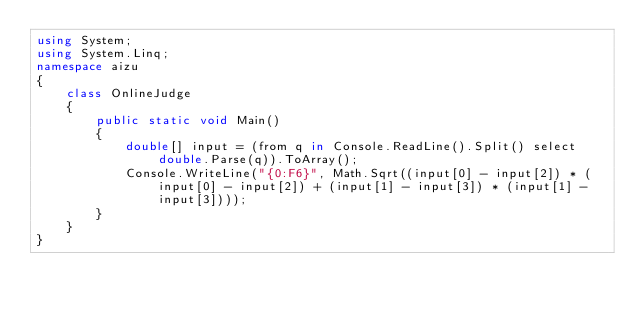Convert code to text. <code><loc_0><loc_0><loc_500><loc_500><_C#_>using System;
using System.Linq;
namespace aizu
{
    class OnlineJudge
    {
        public static void Main()
        {
            double[] input = (from q in Console.ReadLine().Split() select double.Parse(q)).ToArray();
            Console.WriteLine("{0:F6}", Math.Sqrt((input[0] - input[2]) * (input[0] - input[2]) + (input[1] - input[3]) * (input[1] - input[3])));
        }
    }
}</code> 